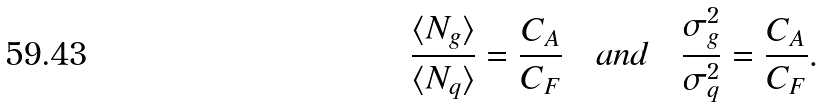<formula> <loc_0><loc_0><loc_500><loc_500>\frac { \langle N _ { g } \rangle } { \langle N _ { q } \rangle } = \frac { C _ { A } } { C _ { F } } \quad a n d \quad \frac { \sigma _ { g } ^ { 2 } } { \sigma _ { q } ^ { 2 } } = \frac { C _ { A } } { C _ { F } } .</formula> 